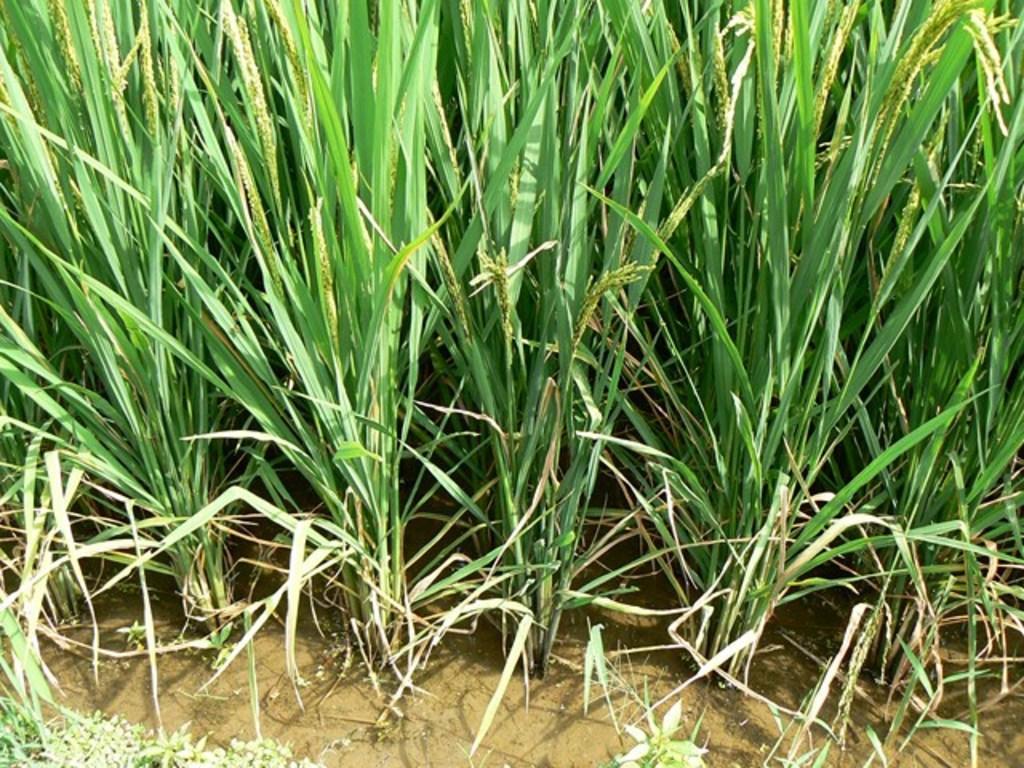How would you summarize this image in a sentence or two? In this image we can see grass plants in the water. 